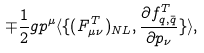<formula> <loc_0><loc_0><loc_500><loc_500>\mp \frac { 1 } { 2 } g p ^ { \mu } \langle \{ ( F _ { \mu \nu } ^ { T } ) _ { N L } , \frac { \partial f _ { q , \bar { q } } ^ { T } } { \partial p _ { \nu } } \} \rangle ,</formula> 